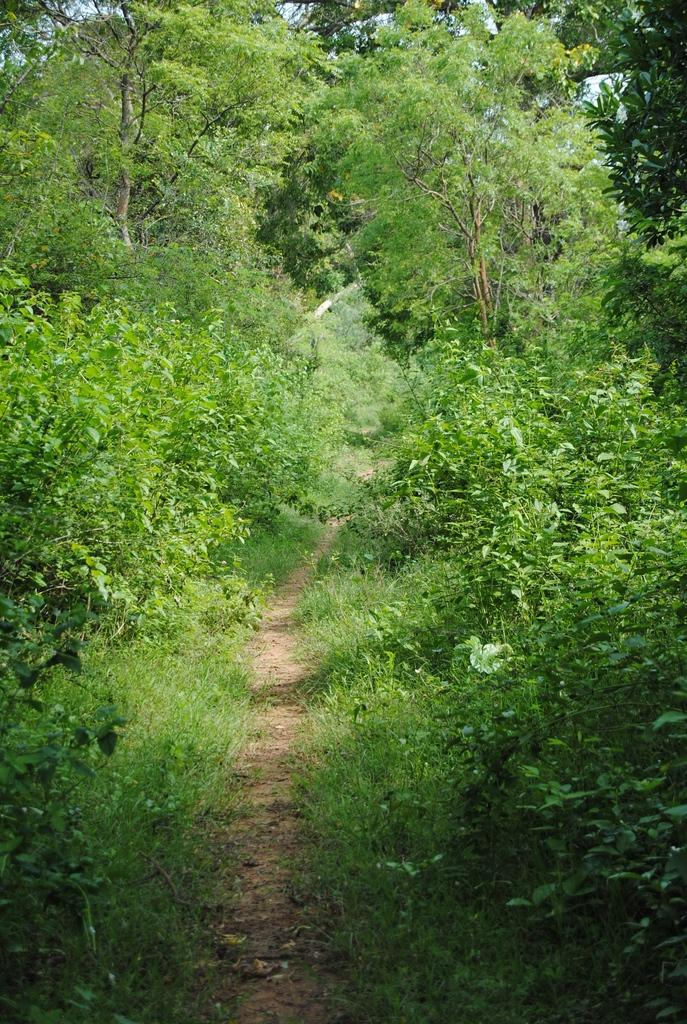What type of vegetation can be seen in the image? There are plants and trees in the image. What part of the natural environment is visible in the image? The sky is visible in the background of the image. What type of treatment is being administered to the plant in the image? There is no treatment being administered to any plant in the image; the plants and trees are simply present in the natural environment. 